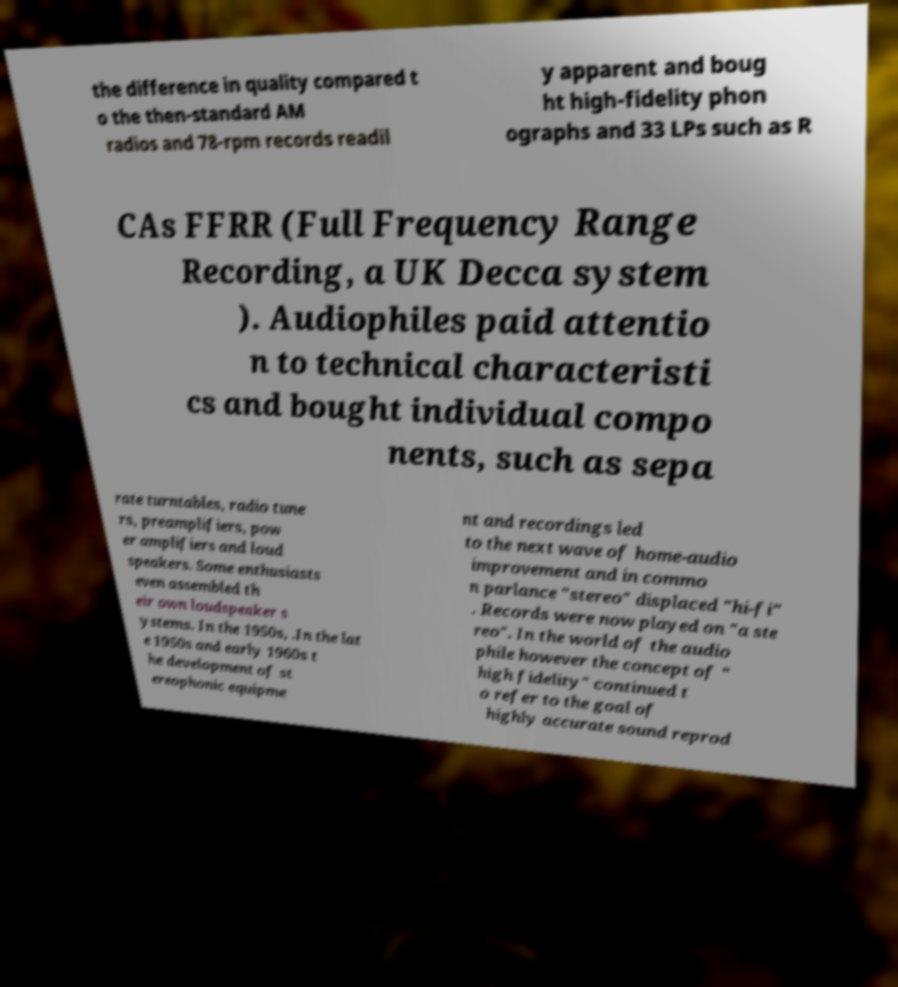I need the written content from this picture converted into text. Can you do that? the difference in quality compared t o the then-standard AM radios and 78-rpm records readil y apparent and boug ht high-fidelity phon ographs and 33 LPs such as R CAs FFRR (Full Frequency Range Recording, a UK Decca system ). Audiophiles paid attentio n to technical characteristi cs and bought individual compo nents, such as sepa rate turntables, radio tune rs, preamplifiers, pow er amplifiers and loud speakers. Some enthusiasts even assembled th eir own loudspeaker s ystems. In the 1950s, .In the lat e 1950s and early 1960s t he development of st ereophonic equipme nt and recordings led to the next wave of home-audio improvement and in commo n parlance "stereo" displaced "hi-fi" . Records were now played on "a ste reo". In the world of the audio phile however the concept of " high fidelity" continued t o refer to the goal of highly accurate sound reprod 